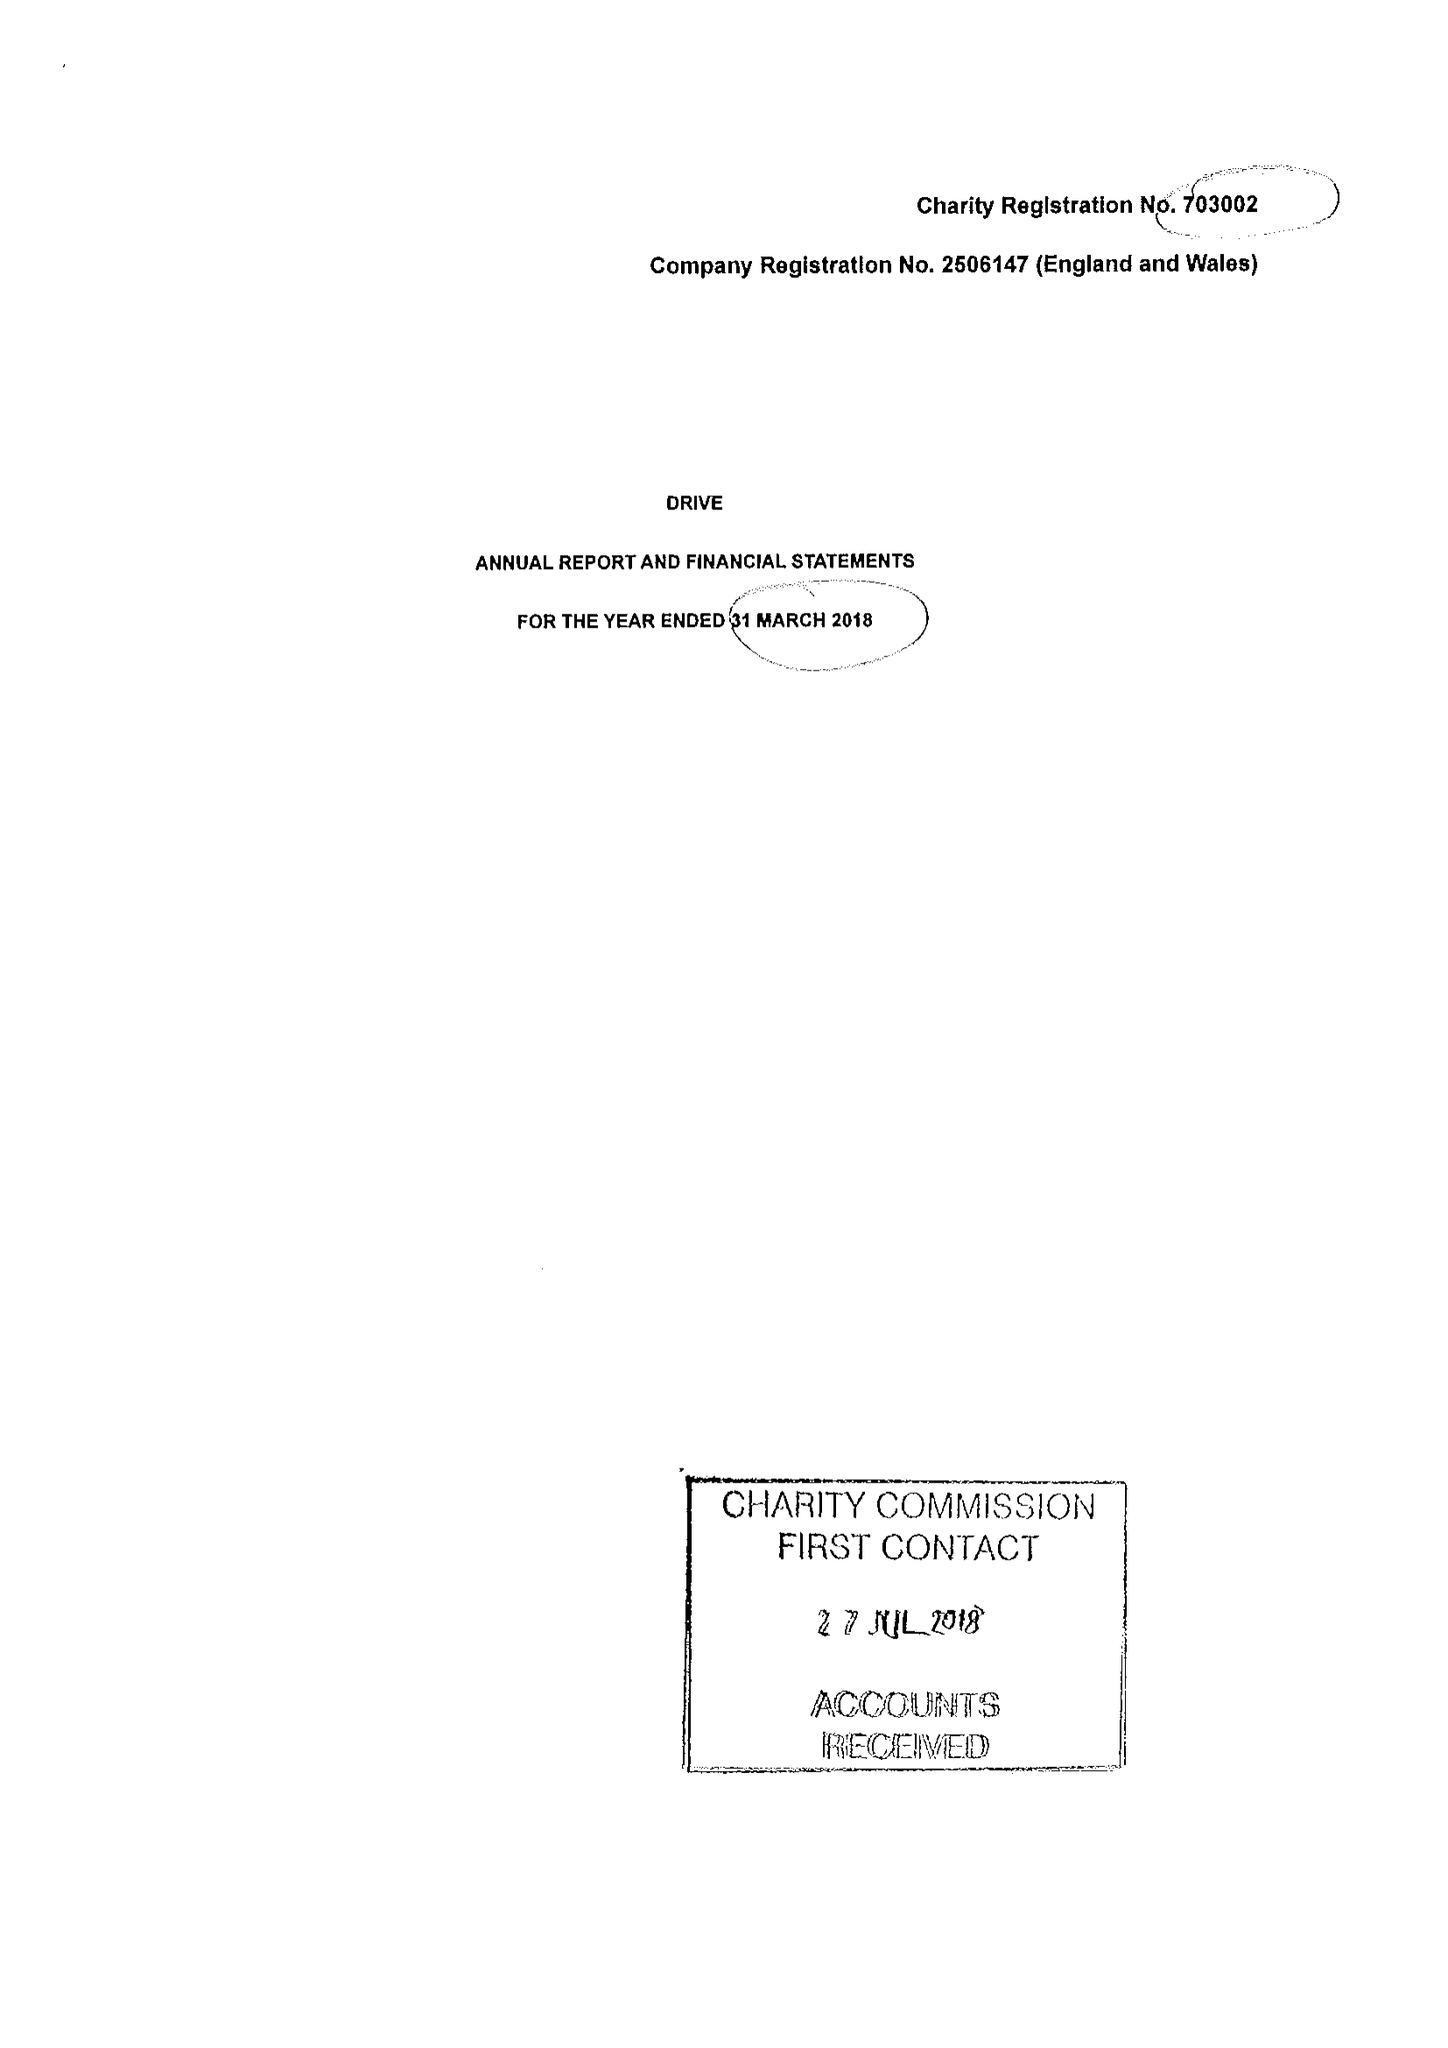What is the value for the spending_annually_in_british_pounds?
Answer the question using a single word or phrase. 14709259.00 